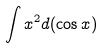<formula> <loc_0><loc_0><loc_500><loc_500>\int x ^ { 2 } d ( \cos x )</formula> 